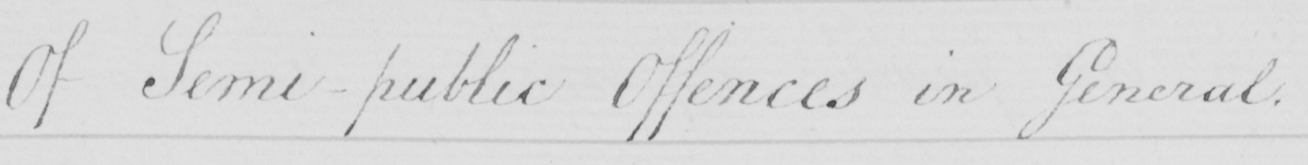What text is written in this handwritten line? Of Semi-public Offences in General . 